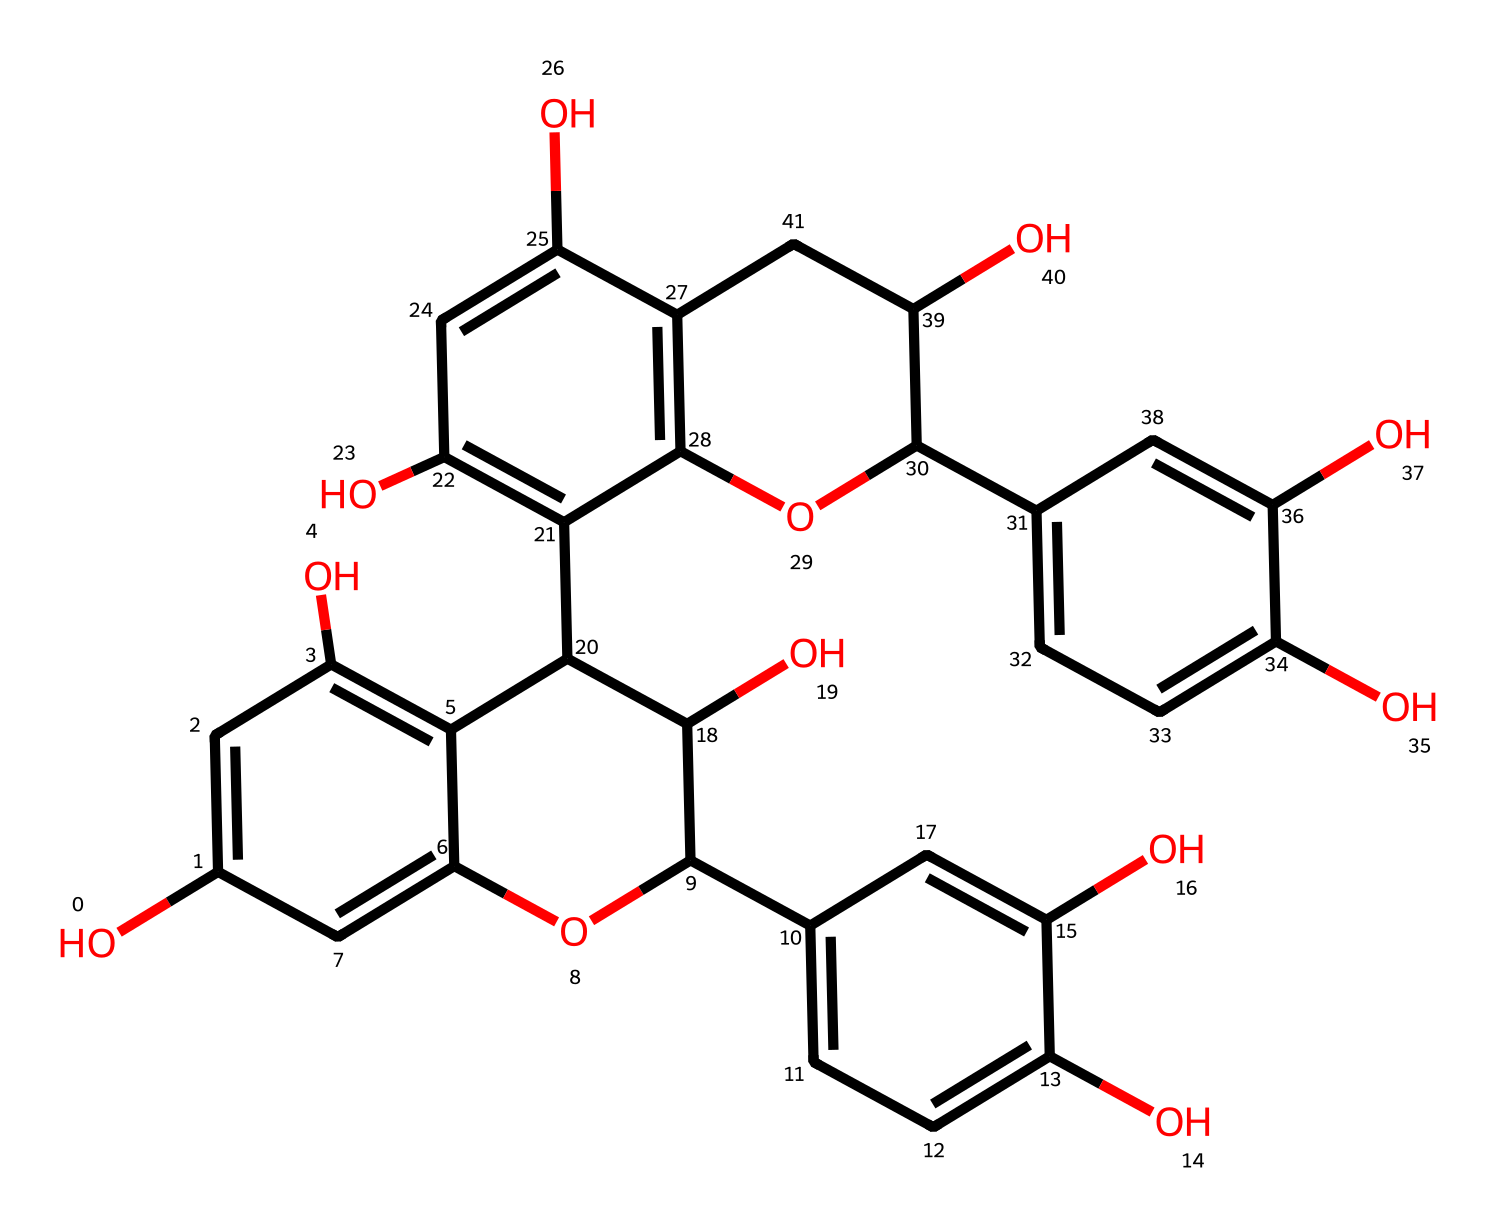What is the molecular formula of the compound represented by the SMILES? To derive the molecular formula from the provided SMILES, we count the carbon (C), hydrogen (H), and oxygen (O) atoms. The given structure indicates a complex aromatic compound. After analyzing the chemical structure visually, we find there are 30 carbon atoms, 26 hydrogen atoms, and 10 oxygen atoms. Thus, the molecular formula is C30H26O10.
Answer: C30H26O10 How many hydroxyl (OH) groups are present in the structure? By examining the chemical structure described in the SMILES, we can identify the hydroxyl (OH) groups which appear as -OH in the structure. Counting these distinctly present hydroxyl groups yields a total of 6.
Answer: 6 Is this compound a flavonoid? The structure shows multiple phenolic hydroxyl groups and the presence of benzene rings, which are typical of flavonoid compounds. There are also several interconnected rings. Therefore, based on these characteristics, we classify it as a flavonoid.
Answer: yes What antioxidant property is associated with the presence of tannins in this compound? Tannins are known for their ability to scavenge free radicals, which helps in antioxidant activity. The structure has many hydroxyl groups capable of donating hydrogen atoms, thus acting as effective antioxidants. Specifically, the multiple aromatic ring systems can stabilize free radicals, enhancing their efficacy as antioxidants.
Answer: free radical scavenging How many aromatic rings are there in the compound? The structure, analyzed from the SMILES representation, reveals distinct rings that belong to aromatic systems. Counting all prominent cyclic structures, we find there are 5 aromatic rings present.
Answer: 5 What role do the phenolic groups play in the antioxidant capability of this compound? The phenolic groups, identifiable as the -OH functional groups attached to aromatic systems in the structure, contribute significantly to the antioxidant capability by enabling the donation of protons. This process alleviates oxidative stress by neutralizing harmful free radicals. Thus, the presence of these groups directly correlates to enhanced antioxidant activity.
Answer: proton donation 